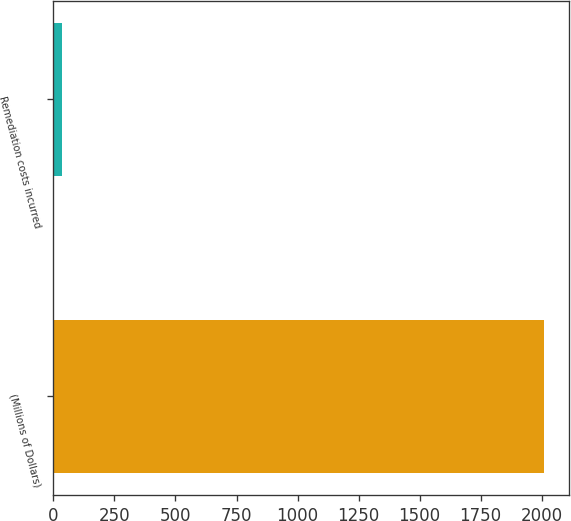<chart> <loc_0><loc_0><loc_500><loc_500><bar_chart><fcel>(Millions of Dollars)<fcel>Remediation costs incurred<nl><fcel>2011<fcel>35<nl></chart> 